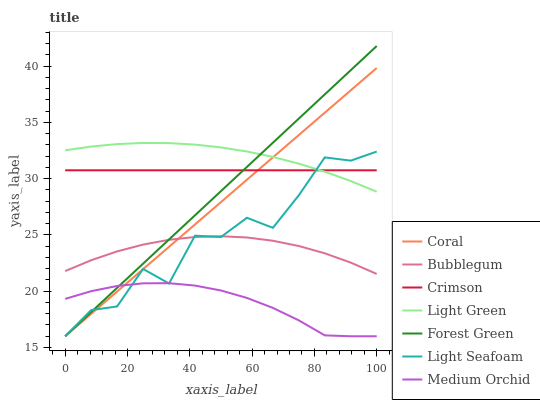Does Medium Orchid have the minimum area under the curve?
Answer yes or no. Yes. Does Light Green have the maximum area under the curve?
Answer yes or no. Yes. Does Bubblegum have the minimum area under the curve?
Answer yes or no. No. Does Bubblegum have the maximum area under the curve?
Answer yes or no. No. Is Forest Green the smoothest?
Answer yes or no. Yes. Is Light Seafoam the roughest?
Answer yes or no. Yes. Is Medium Orchid the smoothest?
Answer yes or no. No. Is Medium Orchid the roughest?
Answer yes or no. No. Does Bubblegum have the lowest value?
Answer yes or no. No. Does Forest Green have the highest value?
Answer yes or no. Yes. Does Bubblegum have the highest value?
Answer yes or no. No. Is Medium Orchid less than Crimson?
Answer yes or no. Yes. Is Bubblegum greater than Medium Orchid?
Answer yes or no. Yes. Does Light Seafoam intersect Light Green?
Answer yes or no. Yes. Is Light Seafoam less than Light Green?
Answer yes or no. No. Is Light Seafoam greater than Light Green?
Answer yes or no. No. Does Medium Orchid intersect Crimson?
Answer yes or no. No. 